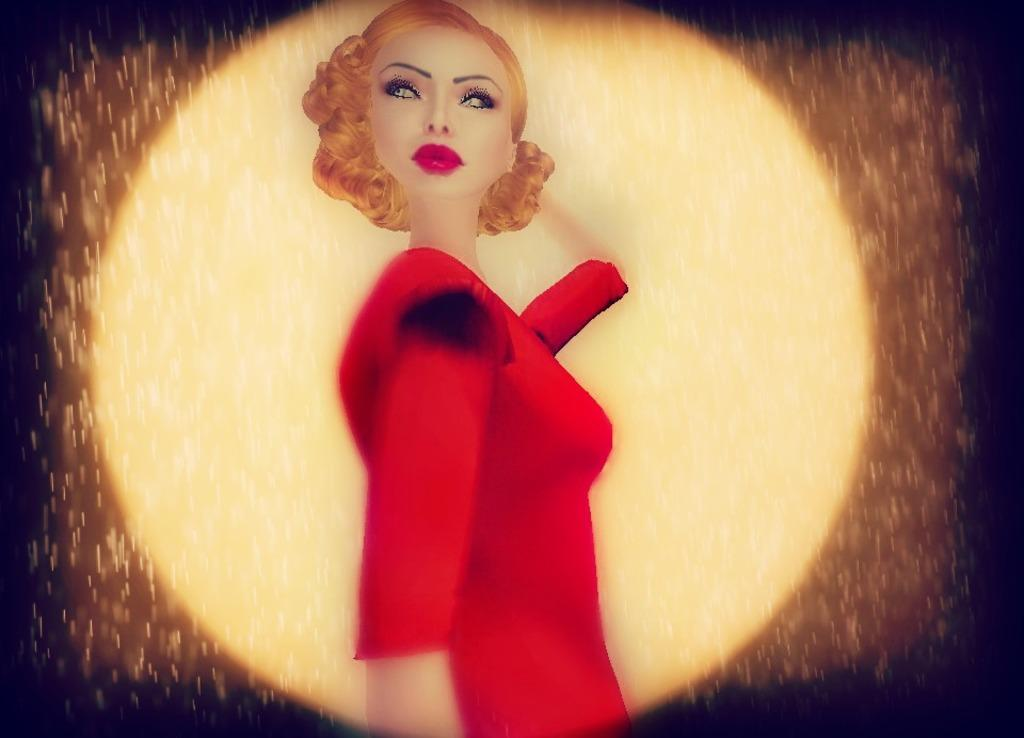What type of picture is in the image? The image contains an animated picture. Can you describe the animated picture? There is a woman in the animated picture. What is the woman wearing in the animated picture? The woman is wearing a red dress in the animated picture. How many girls are sitting at the table in the image? There is no table or girl present in the image; it contains an animated picture of a woman wearing a red dress. 